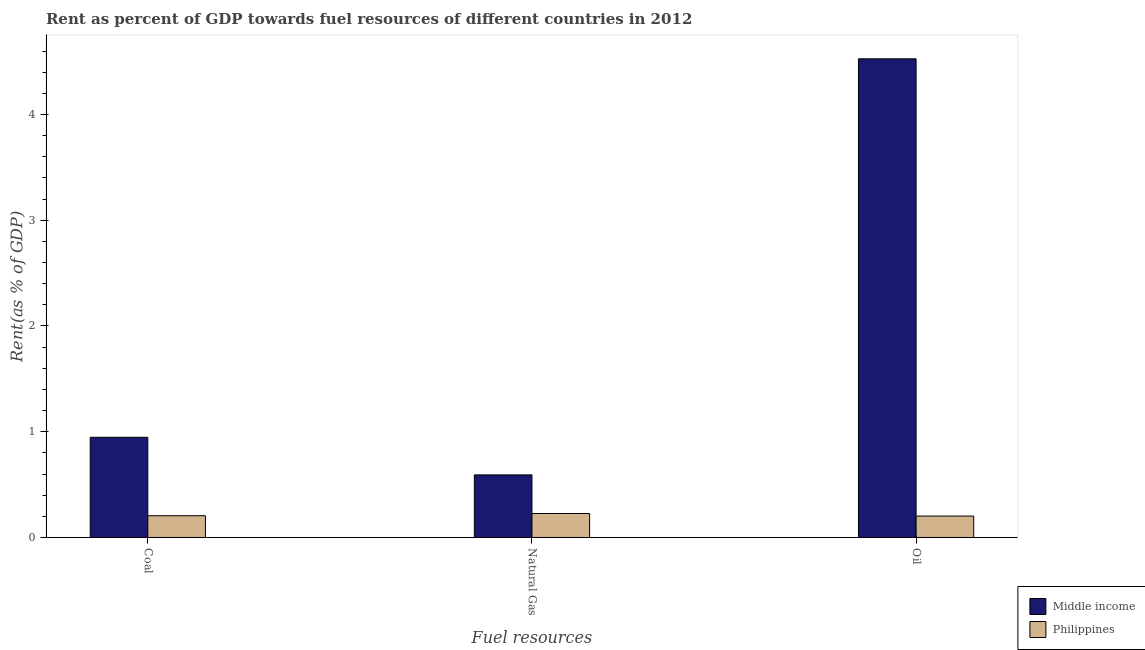How many different coloured bars are there?
Provide a short and direct response. 2. How many bars are there on the 1st tick from the right?
Give a very brief answer. 2. What is the label of the 3rd group of bars from the left?
Give a very brief answer. Oil. What is the rent towards natural gas in Philippines?
Make the answer very short. 0.23. Across all countries, what is the maximum rent towards oil?
Your answer should be very brief. 4.53. Across all countries, what is the minimum rent towards coal?
Your response must be concise. 0.21. In which country was the rent towards coal maximum?
Offer a terse response. Middle income. In which country was the rent towards coal minimum?
Offer a terse response. Philippines. What is the total rent towards oil in the graph?
Your answer should be very brief. 4.73. What is the difference between the rent towards oil in Middle income and that in Philippines?
Your answer should be compact. 4.32. What is the difference between the rent towards oil in Philippines and the rent towards natural gas in Middle income?
Give a very brief answer. -0.39. What is the average rent towards oil per country?
Your answer should be compact. 2.36. What is the difference between the rent towards coal and rent towards natural gas in Middle income?
Make the answer very short. 0.36. In how many countries, is the rent towards coal greater than 1 %?
Provide a short and direct response. 0. What is the ratio of the rent towards coal in Middle income to that in Philippines?
Offer a very short reply. 4.6. Is the difference between the rent towards oil in Philippines and Middle income greater than the difference between the rent towards coal in Philippines and Middle income?
Your response must be concise. No. What is the difference between the highest and the second highest rent towards natural gas?
Make the answer very short. 0.37. What is the difference between the highest and the lowest rent towards coal?
Provide a short and direct response. 0.74. Is the sum of the rent towards coal in Middle income and Philippines greater than the maximum rent towards natural gas across all countries?
Keep it short and to the point. Yes. What does the 1st bar from the right in Coal represents?
Ensure brevity in your answer.  Philippines. Is it the case that in every country, the sum of the rent towards coal and rent towards natural gas is greater than the rent towards oil?
Provide a short and direct response. No. Are all the bars in the graph horizontal?
Offer a terse response. No. How many countries are there in the graph?
Offer a terse response. 2. What is the title of the graph?
Your response must be concise. Rent as percent of GDP towards fuel resources of different countries in 2012. What is the label or title of the X-axis?
Ensure brevity in your answer.  Fuel resources. What is the label or title of the Y-axis?
Give a very brief answer. Rent(as % of GDP). What is the Rent(as % of GDP) of Middle income in Coal?
Make the answer very short. 0.95. What is the Rent(as % of GDP) of Philippines in Coal?
Your answer should be very brief. 0.21. What is the Rent(as % of GDP) of Middle income in Natural Gas?
Give a very brief answer. 0.59. What is the Rent(as % of GDP) of Philippines in Natural Gas?
Your response must be concise. 0.23. What is the Rent(as % of GDP) of Middle income in Oil?
Your answer should be compact. 4.53. What is the Rent(as % of GDP) in Philippines in Oil?
Offer a terse response. 0.2. Across all Fuel resources, what is the maximum Rent(as % of GDP) in Middle income?
Offer a very short reply. 4.53. Across all Fuel resources, what is the maximum Rent(as % of GDP) of Philippines?
Ensure brevity in your answer.  0.23. Across all Fuel resources, what is the minimum Rent(as % of GDP) of Middle income?
Your answer should be very brief. 0.59. Across all Fuel resources, what is the minimum Rent(as % of GDP) in Philippines?
Give a very brief answer. 0.2. What is the total Rent(as % of GDP) in Middle income in the graph?
Make the answer very short. 6.07. What is the total Rent(as % of GDP) in Philippines in the graph?
Offer a very short reply. 0.64. What is the difference between the Rent(as % of GDP) in Middle income in Coal and that in Natural Gas?
Offer a terse response. 0.36. What is the difference between the Rent(as % of GDP) in Philippines in Coal and that in Natural Gas?
Give a very brief answer. -0.02. What is the difference between the Rent(as % of GDP) of Middle income in Coal and that in Oil?
Give a very brief answer. -3.58. What is the difference between the Rent(as % of GDP) in Philippines in Coal and that in Oil?
Offer a very short reply. 0. What is the difference between the Rent(as % of GDP) in Middle income in Natural Gas and that in Oil?
Your response must be concise. -3.93. What is the difference between the Rent(as % of GDP) of Philippines in Natural Gas and that in Oil?
Your response must be concise. 0.02. What is the difference between the Rent(as % of GDP) in Middle income in Coal and the Rent(as % of GDP) in Philippines in Natural Gas?
Your response must be concise. 0.72. What is the difference between the Rent(as % of GDP) in Middle income in Coal and the Rent(as % of GDP) in Philippines in Oil?
Offer a terse response. 0.75. What is the difference between the Rent(as % of GDP) of Middle income in Natural Gas and the Rent(as % of GDP) of Philippines in Oil?
Make the answer very short. 0.39. What is the average Rent(as % of GDP) of Middle income per Fuel resources?
Offer a very short reply. 2.02. What is the average Rent(as % of GDP) of Philippines per Fuel resources?
Provide a short and direct response. 0.21. What is the difference between the Rent(as % of GDP) of Middle income and Rent(as % of GDP) of Philippines in Coal?
Make the answer very short. 0.74. What is the difference between the Rent(as % of GDP) in Middle income and Rent(as % of GDP) in Philippines in Natural Gas?
Your answer should be compact. 0.37. What is the difference between the Rent(as % of GDP) of Middle income and Rent(as % of GDP) of Philippines in Oil?
Your response must be concise. 4.32. What is the ratio of the Rent(as % of GDP) in Middle income in Coal to that in Natural Gas?
Offer a very short reply. 1.6. What is the ratio of the Rent(as % of GDP) in Philippines in Coal to that in Natural Gas?
Give a very brief answer. 0.91. What is the ratio of the Rent(as % of GDP) of Middle income in Coal to that in Oil?
Offer a terse response. 0.21. What is the ratio of the Rent(as % of GDP) of Philippines in Coal to that in Oil?
Your answer should be compact. 1.02. What is the ratio of the Rent(as % of GDP) of Middle income in Natural Gas to that in Oil?
Your response must be concise. 0.13. What is the ratio of the Rent(as % of GDP) of Philippines in Natural Gas to that in Oil?
Provide a short and direct response. 1.12. What is the difference between the highest and the second highest Rent(as % of GDP) in Middle income?
Offer a very short reply. 3.58. What is the difference between the highest and the second highest Rent(as % of GDP) of Philippines?
Keep it short and to the point. 0.02. What is the difference between the highest and the lowest Rent(as % of GDP) of Middle income?
Keep it short and to the point. 3.93. What is the difference between the highest and the lowest Rent(as % of GDP) of Philippines?
Your answer should be very brief. 0.02. 